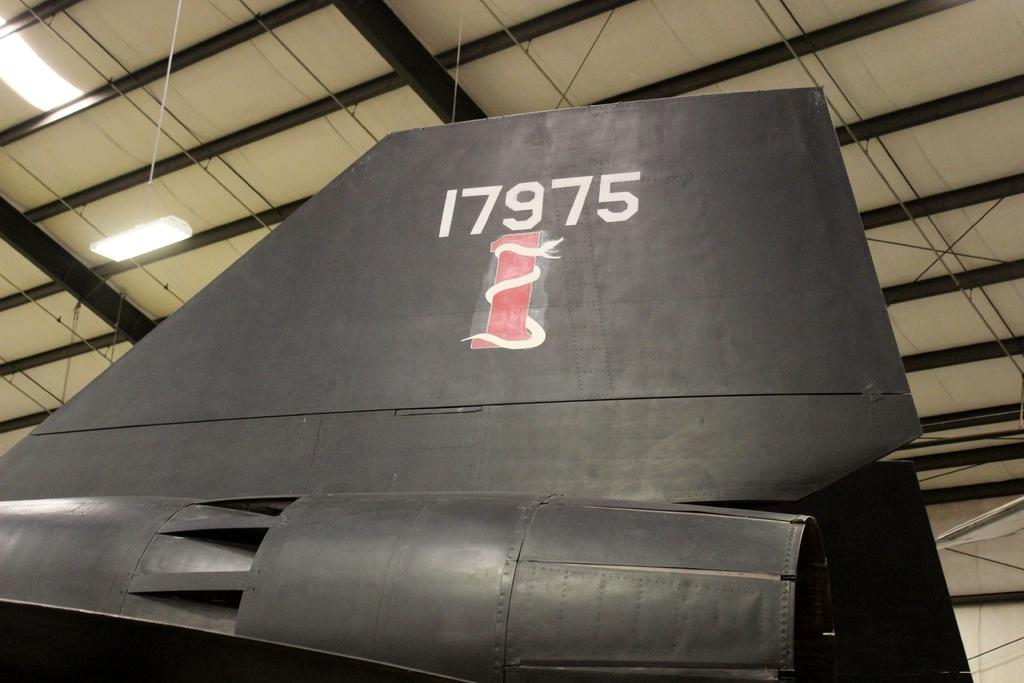<image>
Give a short and clear explanation of the subsequent image. A snake is slithering along a red pole beneath the numbers 17975 on the rudder. 